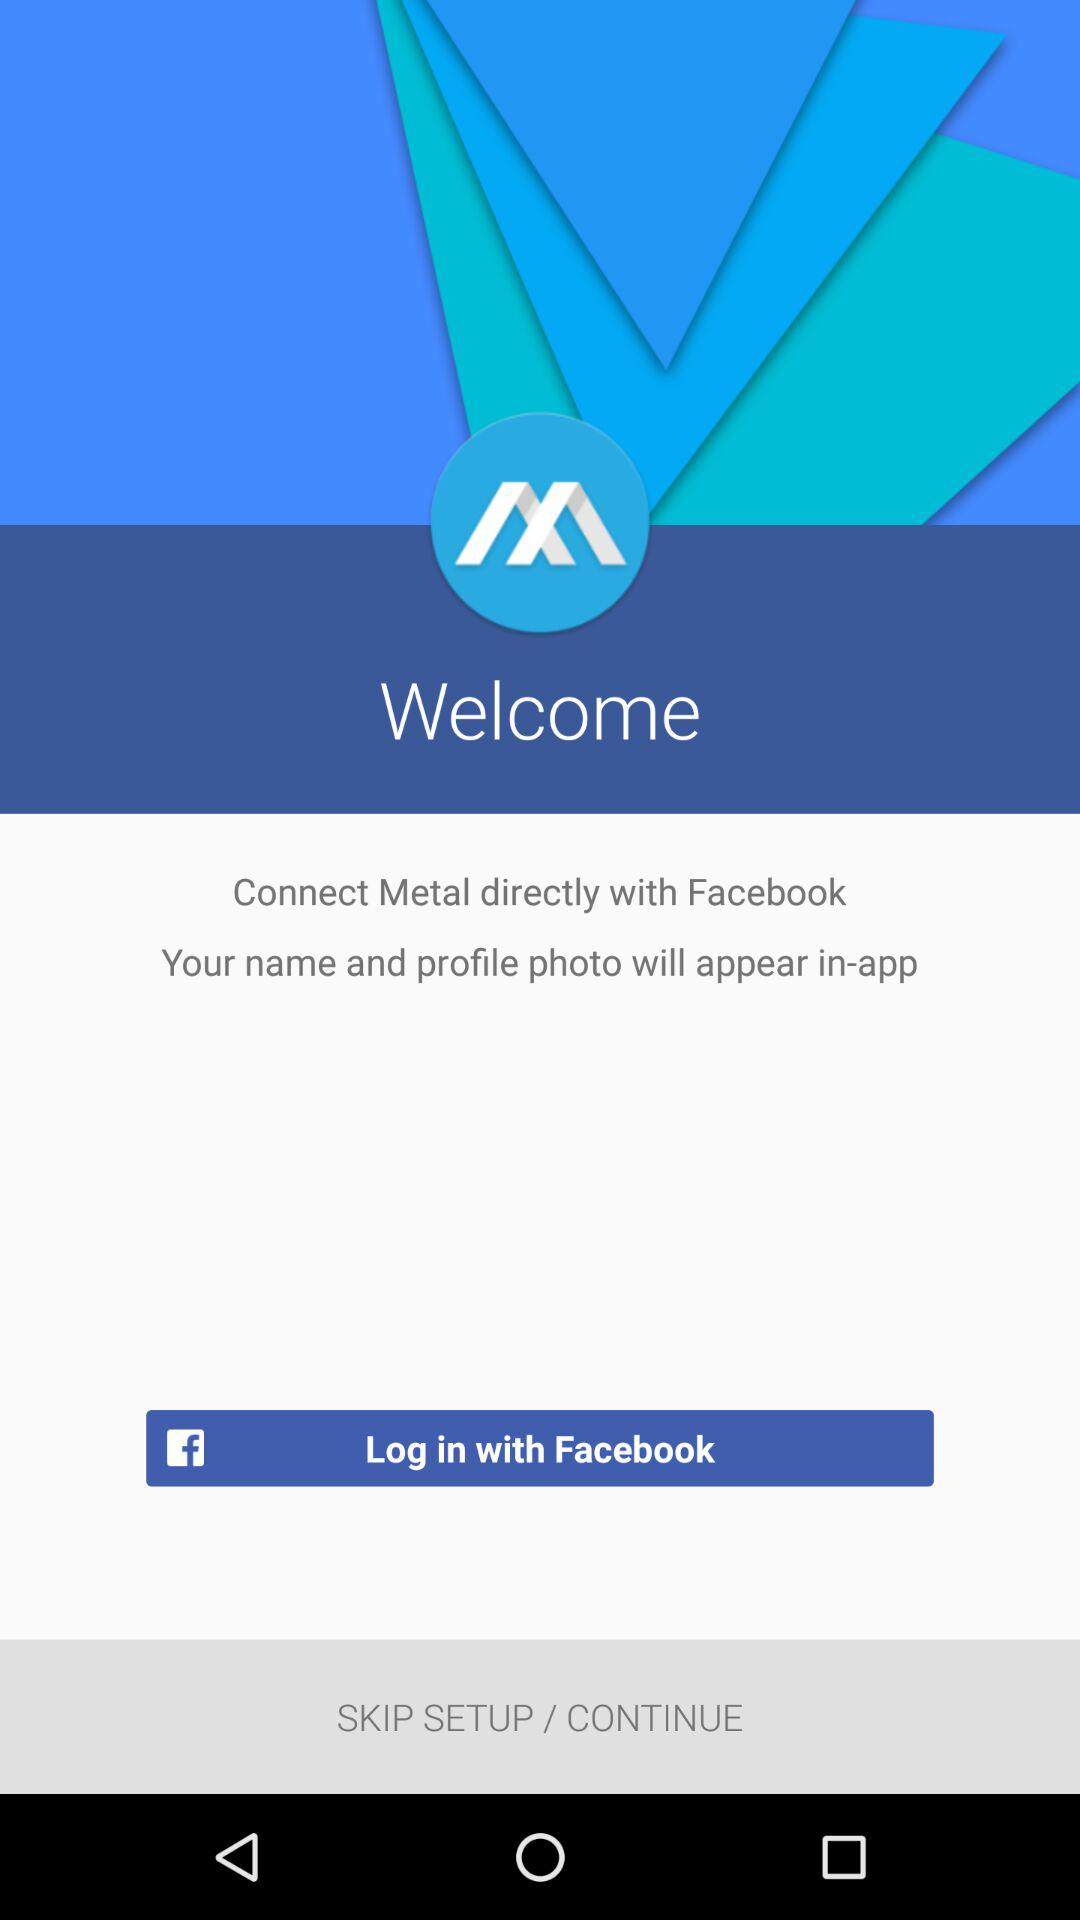What accounts can be used to log in? The account that can be used to log in is "Facebook". 